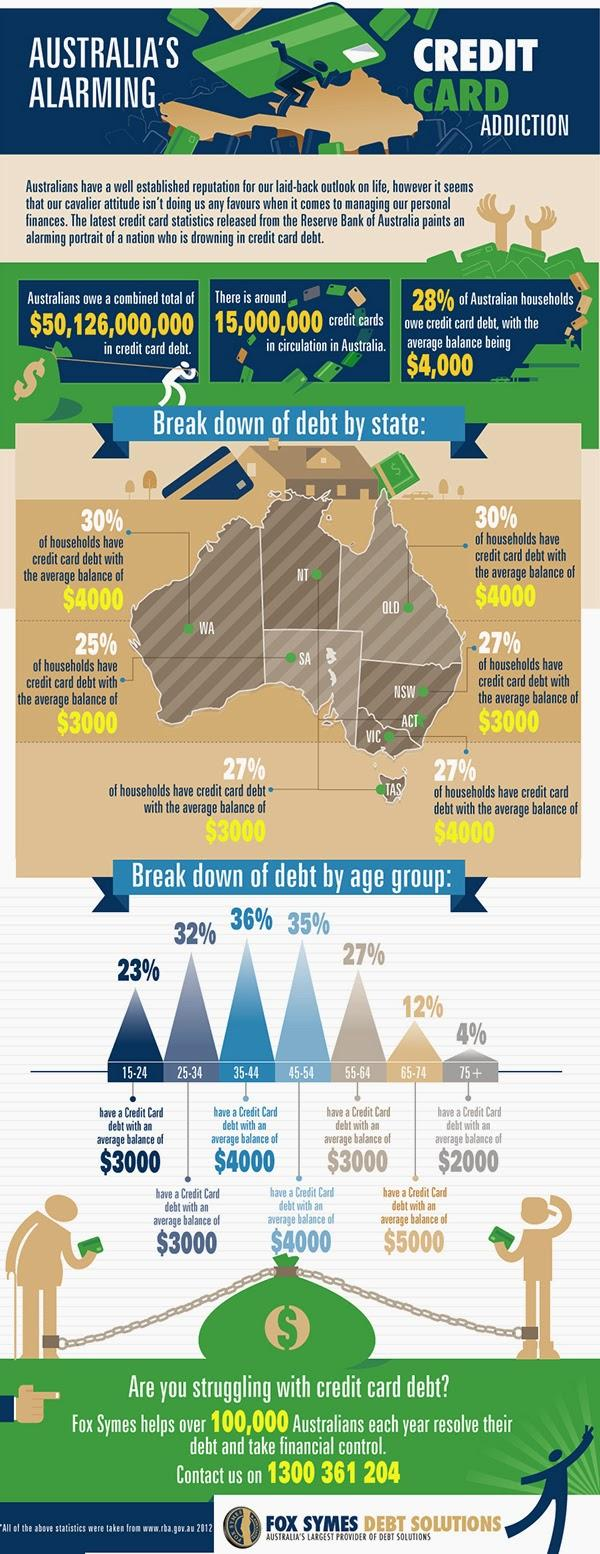Point out several critical features in this image. In Tasmania, 27% of households have credit card debt, with an average balance of $3000, according to the data. The age group of Australians with credit card debt of $2000 on average is 75 and older. In New South Wales, approximately 27% of households have credit card debt, with an average balance of $3,000 per household. In Western Australia, 30% of households have credit card debt, with an average balance of $4,000 per household. The age group of Australians with a credit card debt averaging $5000 is 65-74 years old. 